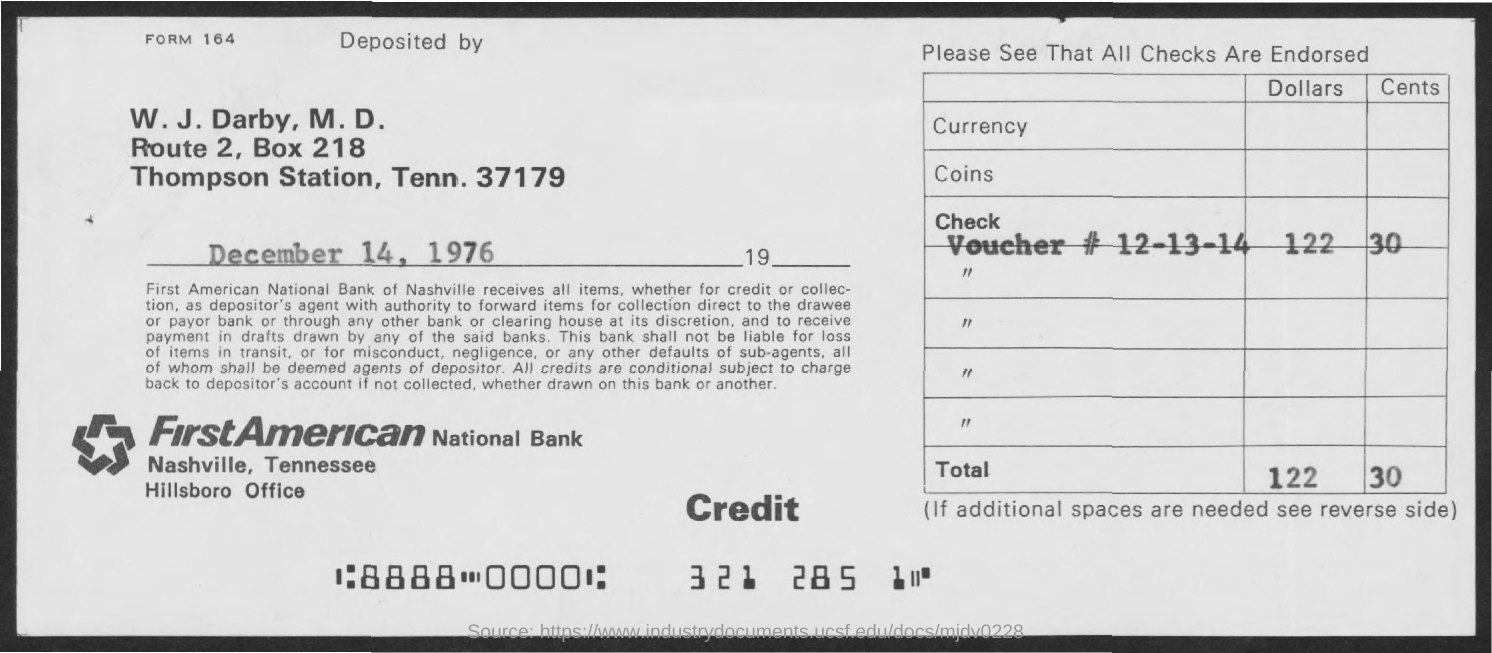Give some essential details in this illustration. The BOX Number is 218. 